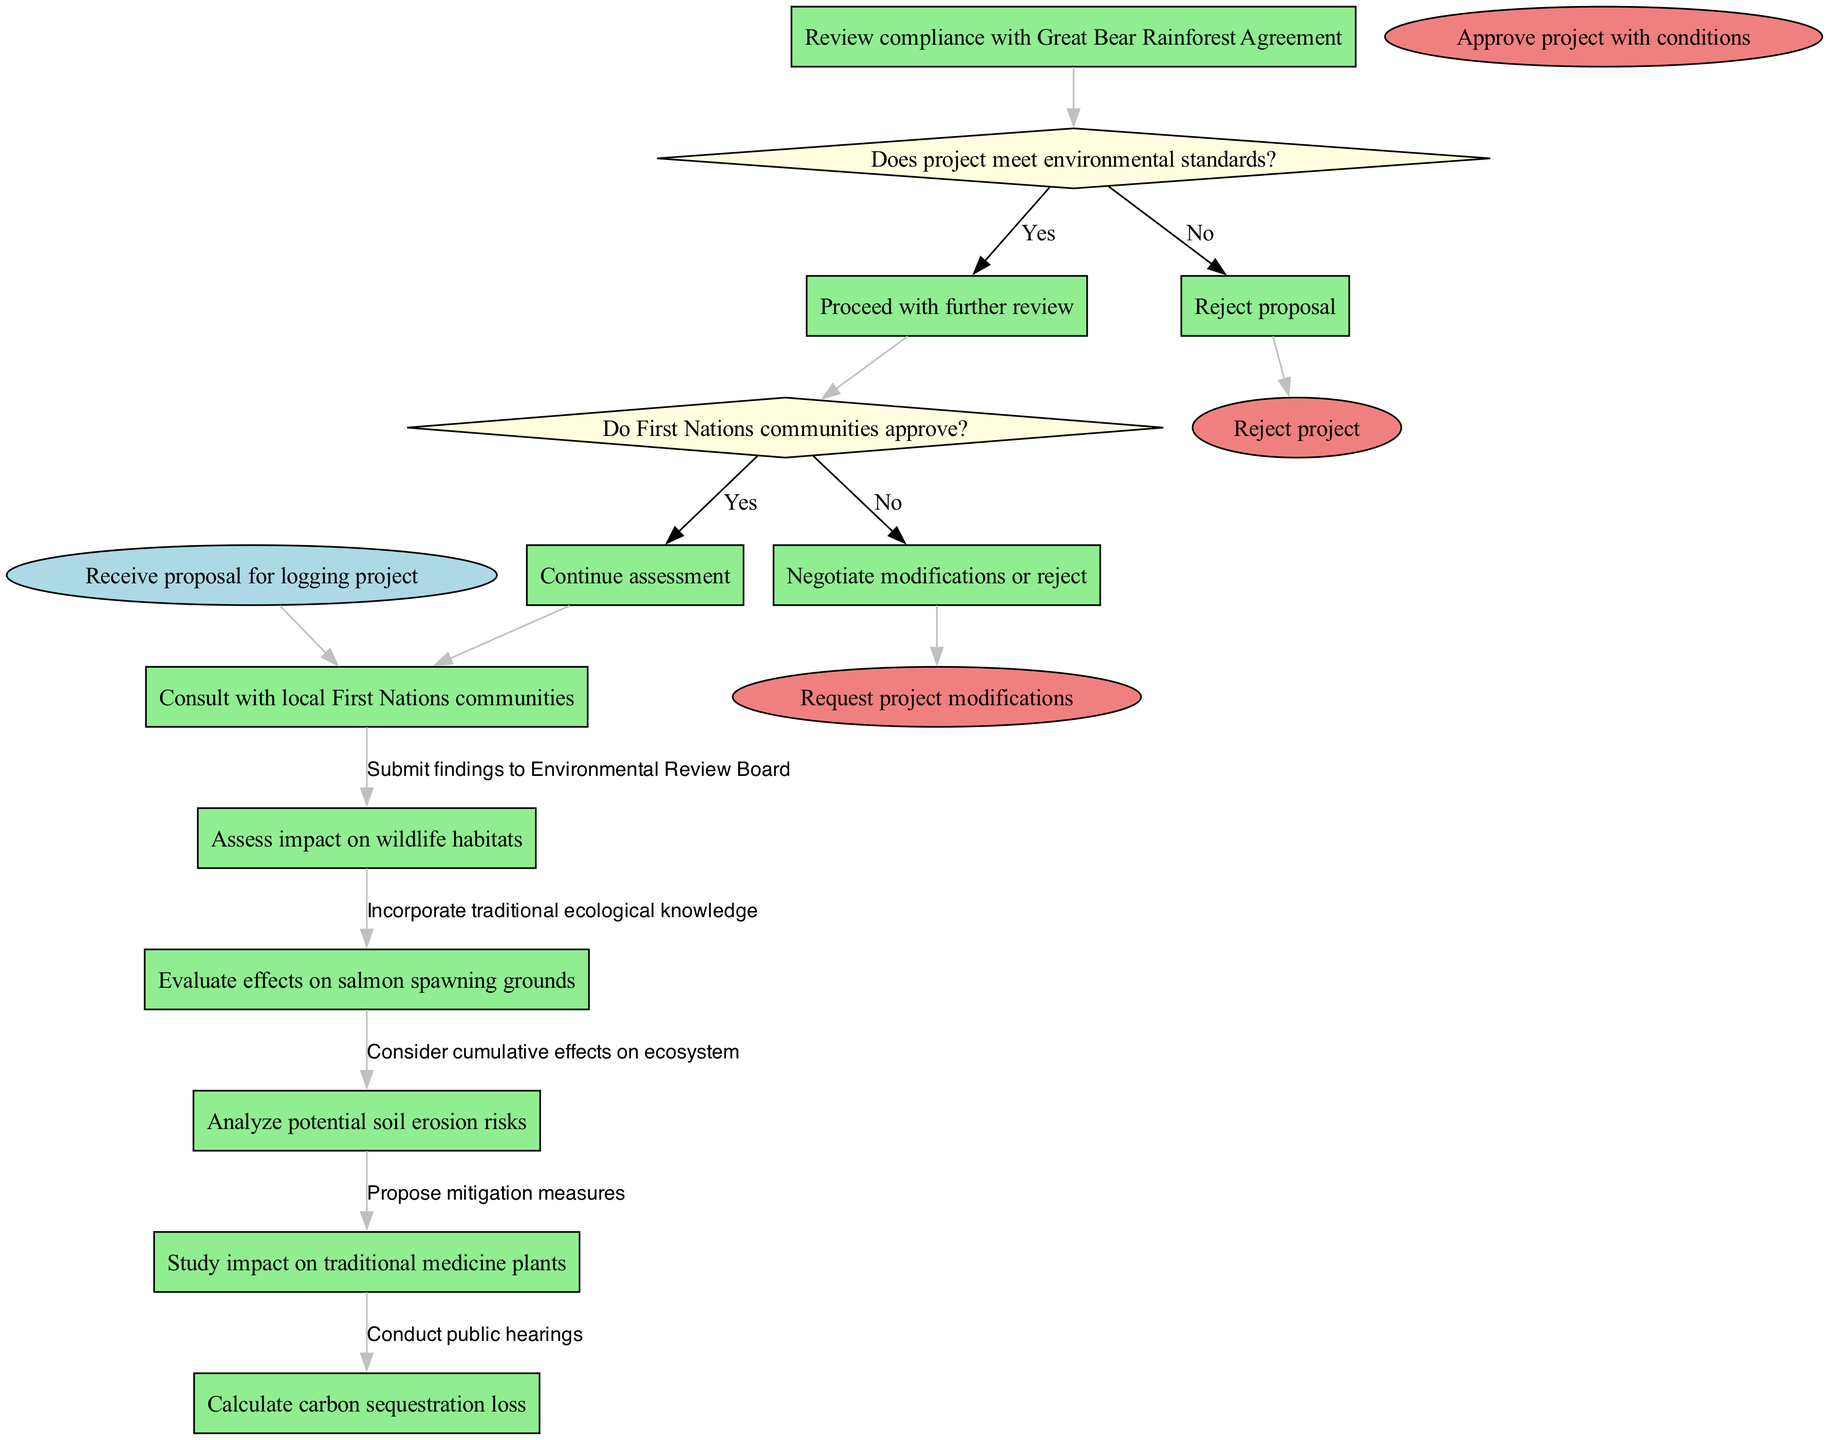What is the first activity in the workflow? The diagram starts with the node labeled "Receive proposal for logging project," which represents the initial step of the workflow.
Answer: Receive proposal for logging project How many decision nodes are present in the diagram? The diagram contains two decision nodes, each representing a condition that determines the subsequent flow in the process.
Answer: 2 What is the last node in the assessment process if the communities reject the proposal? According to the flow, if the First Nations communities do not approve, the pathway leads to the node labeled "Negotiate modifications or reject," which signifies the end of the proposal under those circumstances.
Answer: Negotiate modifications or reject If the proposal meets environmental standards, which decision node follows next? If the project meets the environmental standards, indicated by a 'Yes' from the first decision node, the flow continues to the second decision node labeled "Do First Nations communities approve?"
Answer: Do First Nations communities approve? What happens if environmental standards are not met? If the proposal does not meet the environmental standards, indicated by a 'No' response from the first decision node, the flow leads directly to the node labeled "Reject proposal."
Answer: Reject proposal Which activity assesses the impact on wildlife habitats? The specific activity categorized as "Assess impact on wildlife habitats" is included in the list of activities and demonstrates a step dedicated to examining wildlife concerns.
Answer: Assess impact on wildlife habitats Which condition leads to the request for project modifications? The request for project modifications arises if the First Nations communities do not approve the proposed project after the second decision node, subsequently leading to negotiations or rejection based on their stance.
Answer: Do First Nations communities approve? (No) How many activities are there before the first decision node? The diagram outlines seven activities, and all of them must be completed before reaching the first decision node regarding environmental standards.
Answer: 7 What is the outcome if the project is approved with conditions? If the project is approved with conditions, it signifies that the proposal has satisfied all necessary evaluations and conditions have been stipulated for its execution, thus marking a positive assessment result.
Answer: Approve project with conditions 